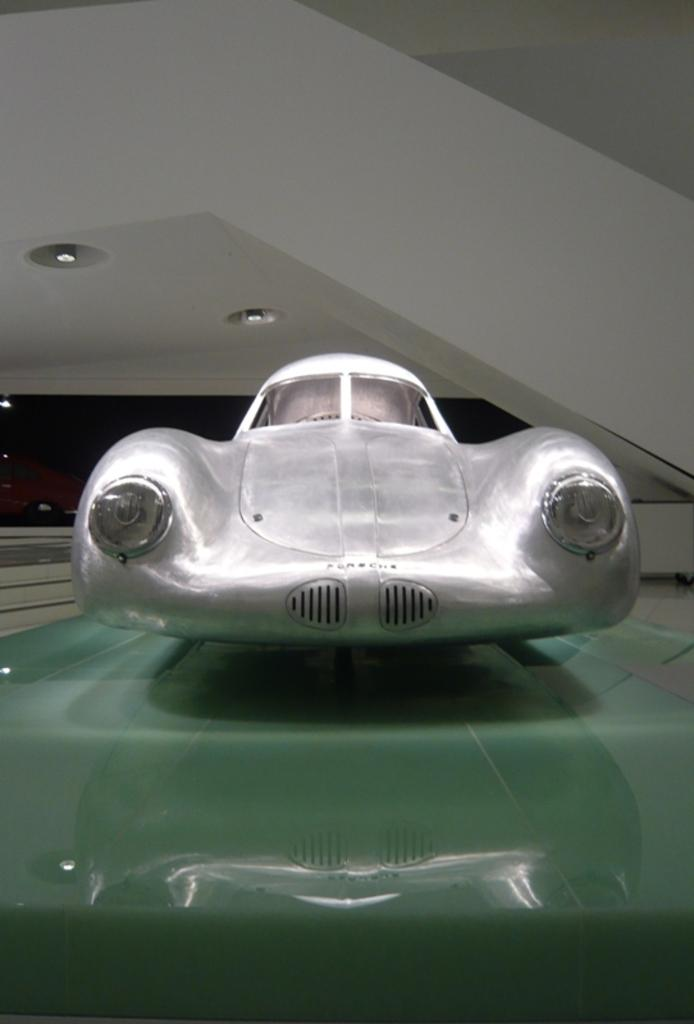What is the color of the vehicle in the image? The vehicle in the image is white. Can you describe the vehicle in the image? The provided facts only mention the color of the vehicle, which is white. What can be seen in the background of the image? There are lights on the ceiling in the background of the image. What type of treatment is being administered to the vehicle in the image? There is no indication in the image that any treatment is being administered to the vehicle. What kind of pan is being used to cook food in the image? There is no pan present in the image. 